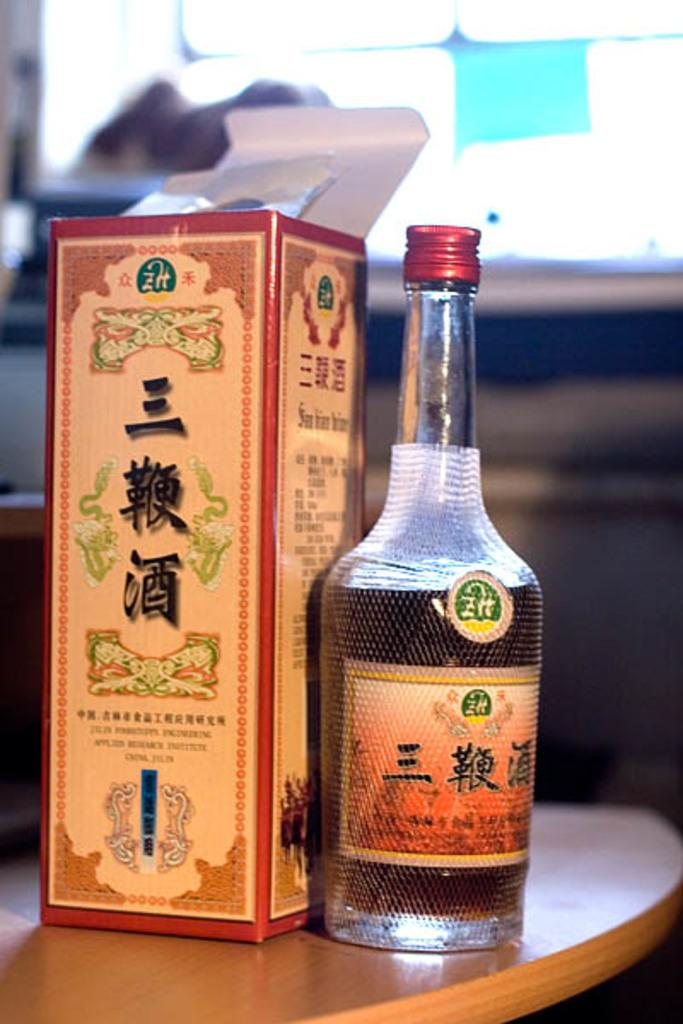What object is present in the image that can hold liquid? There is a bottle in the image that can hold liquid. Is there anything covering the opening of the bottle? Yes, there is a bottle cover in the image. Where is the bottle located? The bottle is on a table. What type of birds can be seen flying through the hole in the image? There is no hole or birds present in the image. 